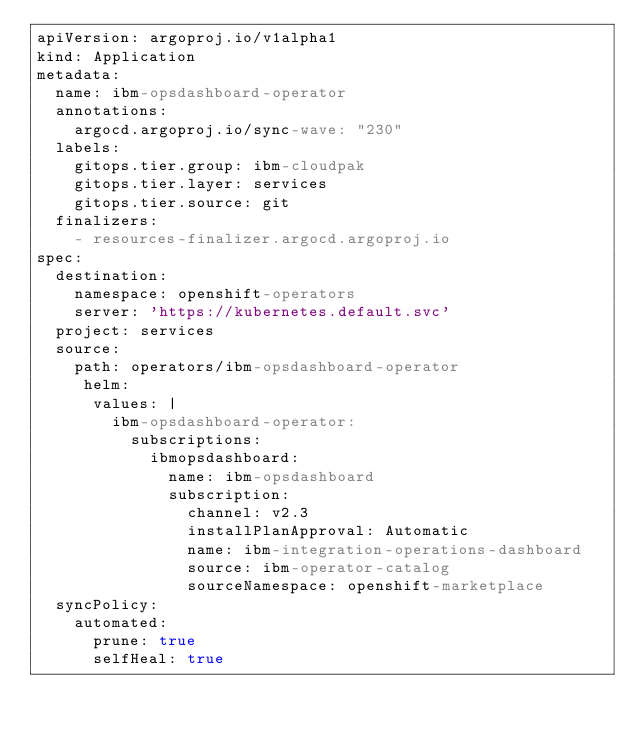Convert code to text. <code><loc_0><loc_0><loc_500><loc_500><_YAML_>apiVersion: argoproj.io/v1alpha1
kind: Application
metadata:
  name: ibm-opsdashboard-operator
  annotations:
    argocd.argoproj.io/sync-wave: "230"
  labels:
    gitops.tier.group: ibm-cloudpak
    gitops.tier.layer: services
    gitops.tier.source: git
  finalizers:
    - resources-finalizer.argocd.argoproj.io
spec:
  destination:
    namespace: openshift-operators
    server: 'https://kubernetes.default.svc'
  project: services
  source:
    path: operators/ibm-opsdashboard-operator
     helm:
      values: |
        ibm-opsdashboard-operator:
          subscriptions:
            ibmopsdashboard:
              name: ibm-opsdashboard
              subscription:
                channel: v2.3
                installPlanApproval: Automatic
                name: ibm-integration-operations-dashboard
                source: ibm-operator-catalog
                sourceNamespace: openshift-marketplace
  syncPolicy:
    automated:
      prune: true
      selfHeal: true
</code> 